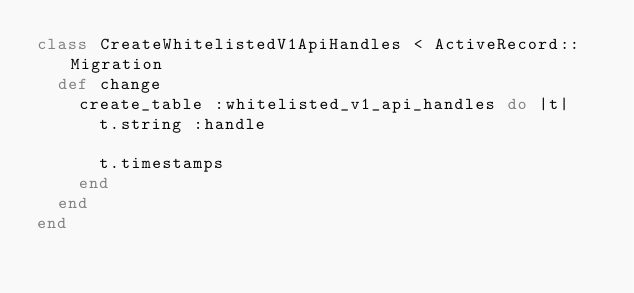<code> <loc_0><loc_0><loc_500><loc_500><_Ruby_>class CreateWhitelistedV1ApiHandles < ActiveRecord::Migration
  def change
    create_table :whitelisted_v1_api_handles do |t|
      t.string :handle

      t.timestamps
    end
  end
end
</code> 